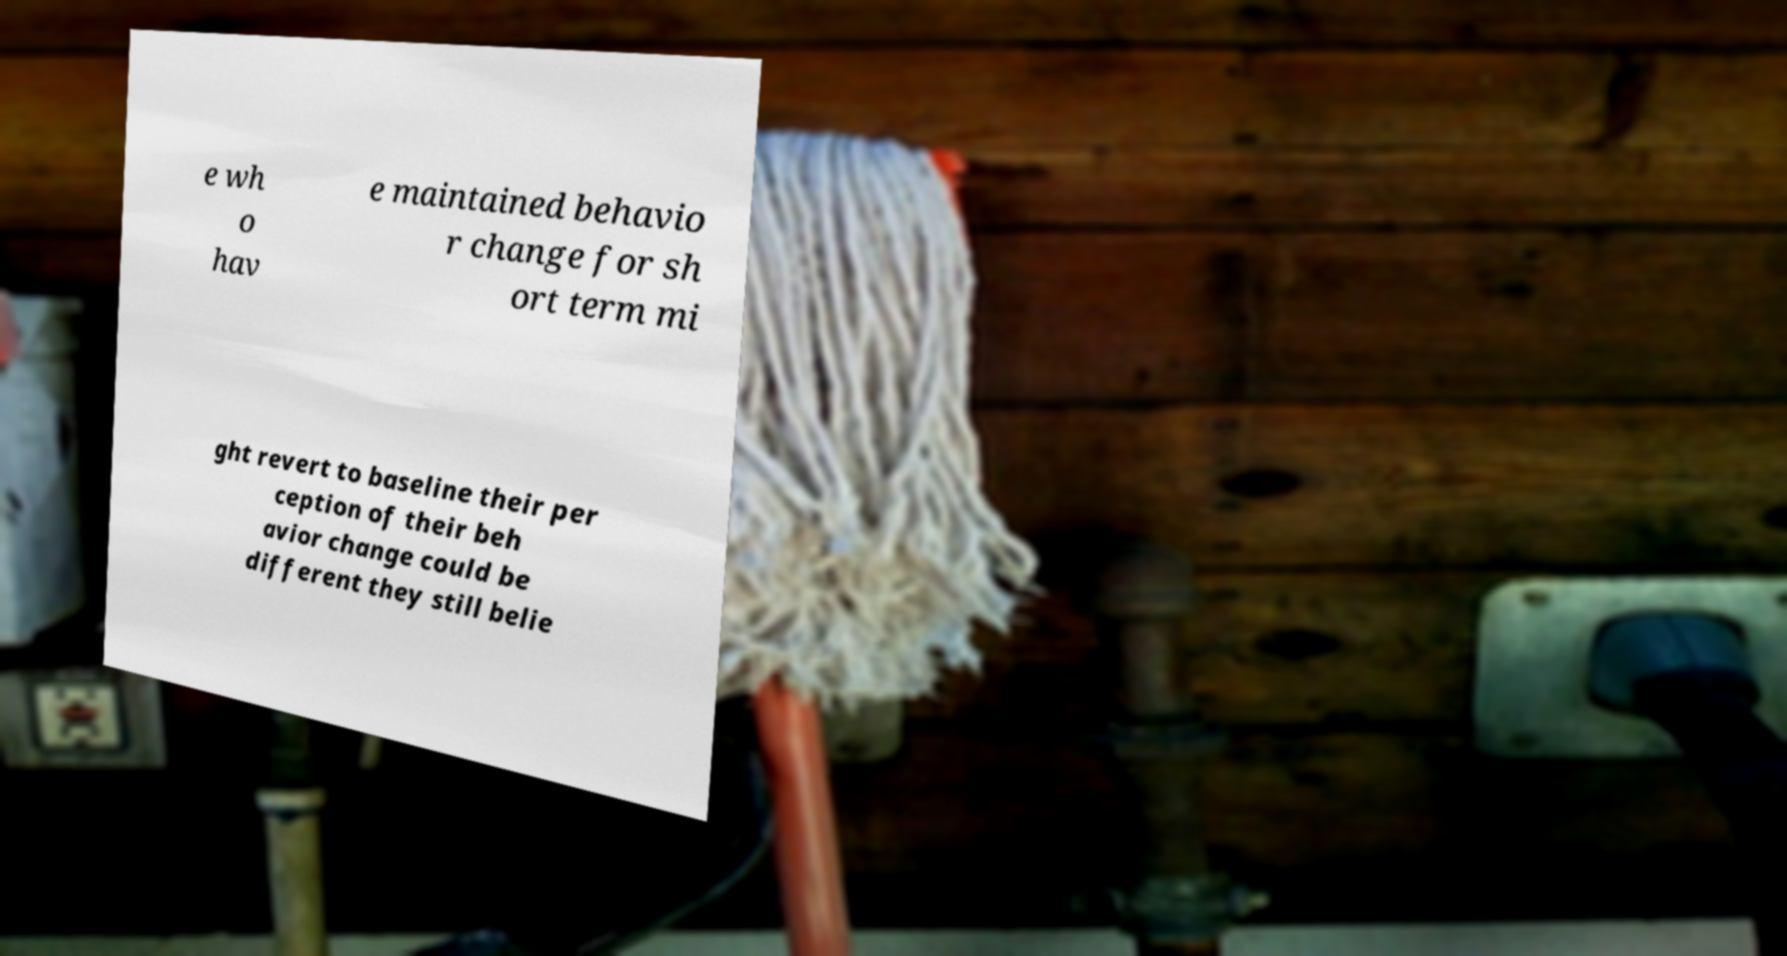Could you assist in decoding the text presented in this image and type it out clearly? e wh o hav e maintained behavio r change for sh ort term mi ght revert to baseline their per ception of their beh avior change could be different they still belie 